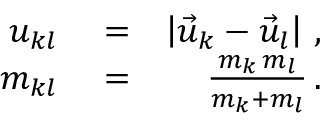Convert formula to latex. <formula><loc_0><loc_0><loc_500><loc_500>\begin{array} { r l r } { u _ { k l } } & = } & { \left | \vec { u } _ { k } - \vec { u } _ { l } \right | \, , } \\ { m _ { k l } } & = } & { \frac { m _ { k } \, m _ { l } } { m _ { k } + m _ { l } } \, . } \end{array}</formula> 